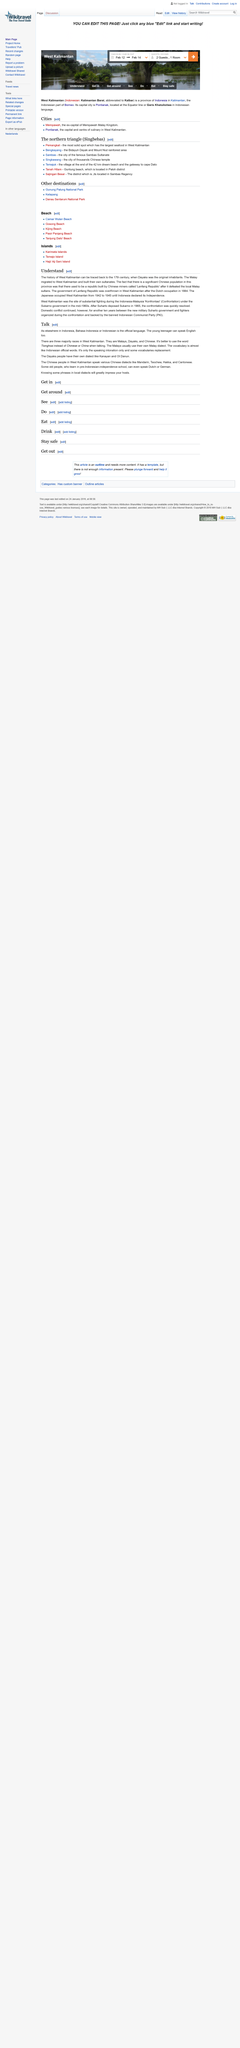Give some essential details in this illustration. The Malays typically use their own Malay dialect, which is commonly spoken in their region. The three majority races in West Kalimantan, Indonesia are the Malays, Dayaks, and Chinese. The Dayaks have two dialects: Kanayan and Ot Danun. 